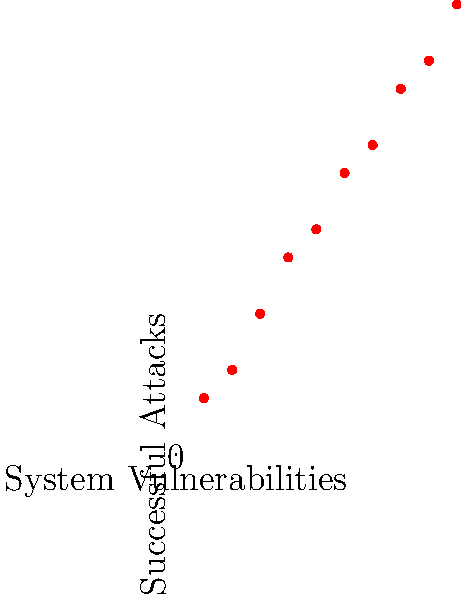Based on the scatter plot showing the relationship between system vulnerabilities and successful attacks, what is the approximate slope of the best-fit line? Round your answer to two decimal places. To find the slope of the best-fit line, we need to follow these steps:

1. Identify two points on the line. Let's choose points at x=1 and x=10 for easier calculation.
2. At x=1, y ≈ 2
   At x=10, y ≈ 16
3. Calculate the slope using the formula:
   $$ m = \frac{y_2 - y_1}{x_2 - x_1} $$
4. Plugging in the values:
   $$ m = \frac{16 - 2}{10 - 1} = \frac{14}{9} ≈ 1.5556 $$
5. Rounding to two decimal places: 1.56

This slope indicates that for each additional system vulnerability, there is an increase of approximately 1.56 successful attacks.
Answer: 1.56 